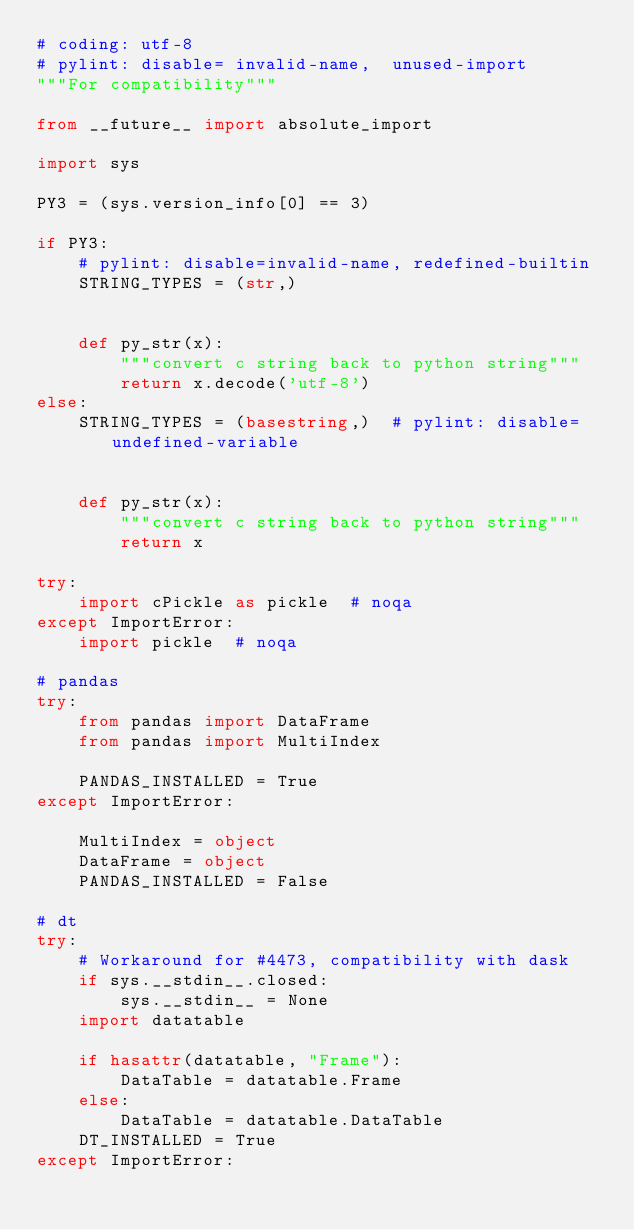<code> <loc_0><loc_0><loc_500><loc_500><_Python_># coding: utf-8
# pylint: disable= invalid-name,  unused-import
"""For compatibility"""

from __future__ import absolute_import

import sys

PY3 = (sys.version_info[0] == 3)

if PY3:
    # pylint: disable=invalid-name, redefined-builtin
    STRING_TYPES = (str,)


    def py_str(x):
        """convert c string back to python string"""
        return x.decode('utf-8')
else:
    STRING_TYPES = (basestring,)  # pylint: disable=undefined-variable


    def py_str(x):
        """convert c string back to python string"""
        return x

try:
    import cPickle as pickle  # noqa
except ImportError:
    import pickle  # noqa

# pandas
try:
    from pandas import DataFrame
    from pandas import MultiIndex

    PANDAS_INSTALLED = True
except ImportError:

    MultiIndex = object
    DataFrame = object
    PANDAS_INSTALLED = False

# dt
try:
    # Workaround for #4473, compatibility with dask
    if sys.__stdin__.closed:
        sys.__stdin__ = None
    import datatable

    if hasattr(datatable, "Frame"):
        DataTable = datatable.Frame
    else:
        DataTable = datatable.DataTable
    DT_INSTALLED = True
except ImportError:
</code> 